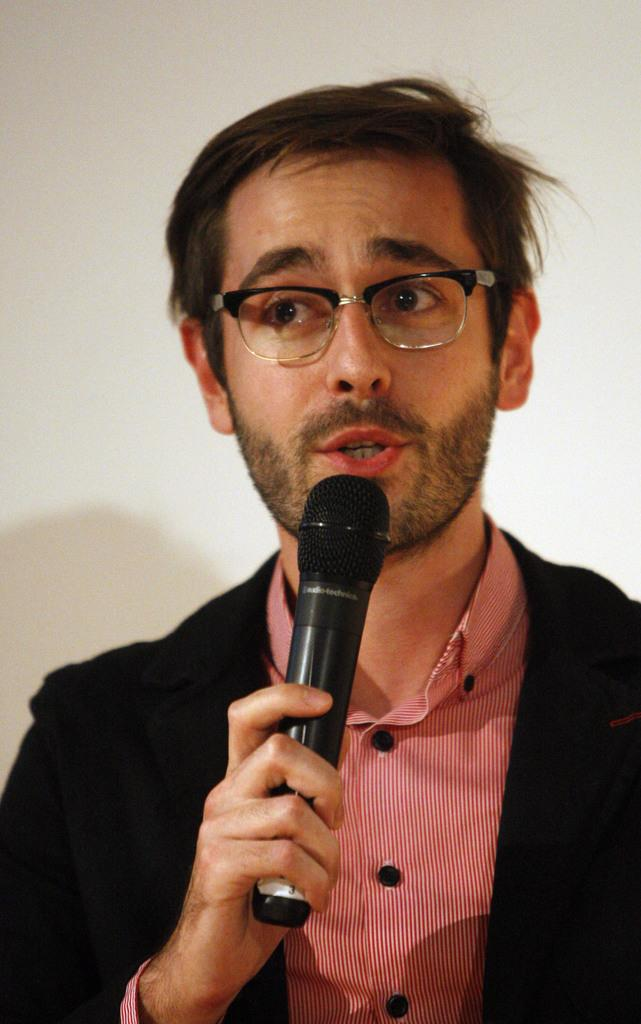What is the main subject of the image? There is a person in the image. What is the person holding in the image? The person is holding a microphone. How many legs does the pan have in the image? There is no pan present in the image, so it is not possible to determine the number of legs it might have. 